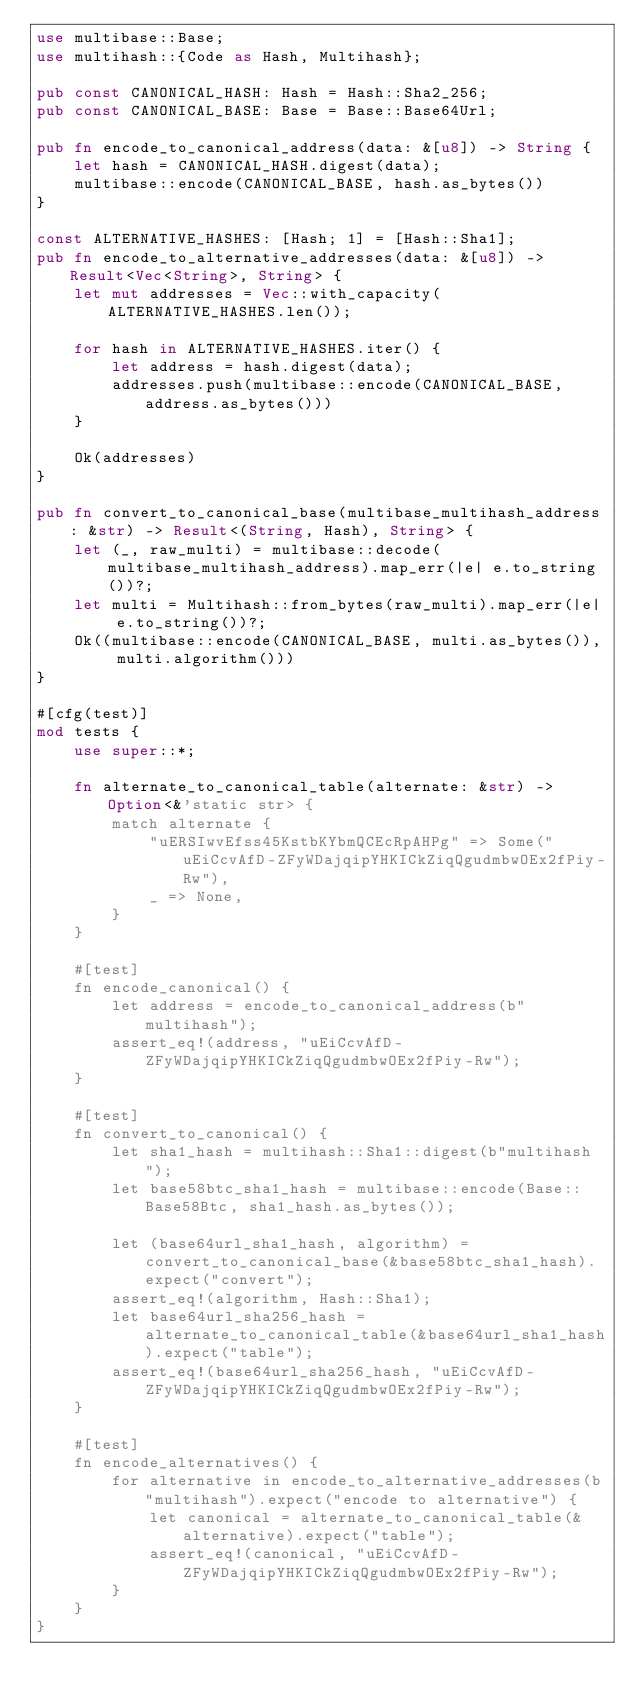<code> <loc_0><loc_0><loc_500><loc_500><_Rust_>use multibase::Base;
use multihash::{Code as Hash, Multihash};

pub const CANONICAL_HASH: Hash = Hash::Sha2_256;
pub const CANONICAL_BASE: Base = Base::Base64Url;

pub fn encode_to_canonical_address(data: &[u8]) -> String {
    let hash = CANONICAL_HASH.digest(data);
    multibase::encode(CANONICAL_BASE, hash.as_bytes())
}

const ALTERNATIVE_HASHES: [Hash; 1] = [Hash::Sha1];
pub fn encode_to_alternative_addresses(data: &[u8]) -> Result<Vec<String>, String> {
    let mut addresses = Vec::with_capacity(ALTERNATIVE_HASHES.len());

    for hash in ALTERNATIVE_HASHES.iter() {
        let address = hash.digest(data);
        addresses.push(multibase::encode(CANONICAL_BASE, address.as_bytes()))
    }

    Ok(addresses)
}

pub fn convert_to_canonical_base(multibase_multihash_address: &str) -> Result<(String, Hash), String> {
    let (_, raw_multi) = multibase::decode(multibase_multihash_address).map_err(|e| e.to_string())?;
    let multi = Multihash::from_bytes(raw_multi).map_err(|e| e.to_string())?;
    Ok((multibase::encode(CANONICAL_BASE, multi.as_bytes()), multi.algorithm()))
}

#[cfg(test)]
mod tests {
    use super::*;

    fn alternate_to_canonical_table(alternate: &str) -> Option<&'static str> {
        match alternate {
            "uERSIwvEfss45KstbKYbmQCEcRpAHPg" => Some("uEiCcvAfD-ZFyWDajqipYHKICkZiqQgudmbwOEx2fPiy-Rw"),
            _ => None,
        }
    }

    #[test]
    fn encode_canonical() {
        let address = encode_to_canonical_address(b"multihash");
        assert_eq!(address, "uEiCcvAfD-ZFyWDajqipYHKICkZiqQgudmbwOEx2fPiy-Rw");
    }

    #[test]
    fn convert_to_canonical() {
        let sha1_hash = multihash::Sha1::digest(b"multihash");
        let base58btc_sha1_hash = multibase::encode(Base::Base58Btc, sha1_hash.as_bytes());

        let (base64url_sha1_hash, algorithm) = convert_to_canonical_base(&base58btc_sha1_hash).expect("convert");
        assert_eq!(algorithm, Hash::Sha1);
        let base64url_sha256_hash = alternate_to_canonical_table(&base64url_sha1_hash).expect("table");
        assert_eq!(base64url_sha256_hash, "uEiCcvAfD-ZFyWDajqipYHKICkZiqQgudmbwOEx2fPiy-Rw");
    }

    #[test]
    fn encode_alternatives() {
        for alternative in encode_to_alternative_addresses(b"multihash").expect("encode to alternative") {
            let canonical = alternate_to_canonical_table(&alternative).expect("table");
            assert_eq!(canonical, "uEiCcvAfD-ZFyWDajqipYHKICkZiqQgudmbwOEx2fPiy-Rw");
        }
    }
}
</code> 